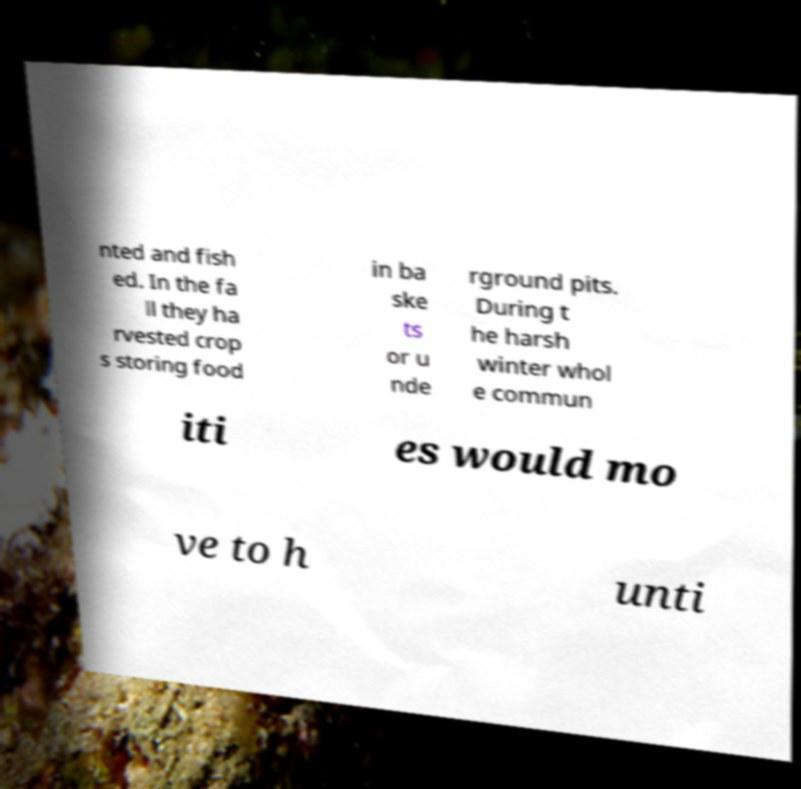I need the written content from this picture converted into text. Can you do that? nted and fish ed. In the fa ll they ha rvested crop s storing food in ba ske ts or u nde rground pits. During t he harsh winter whol e commun iti es would mo ve to h unti 